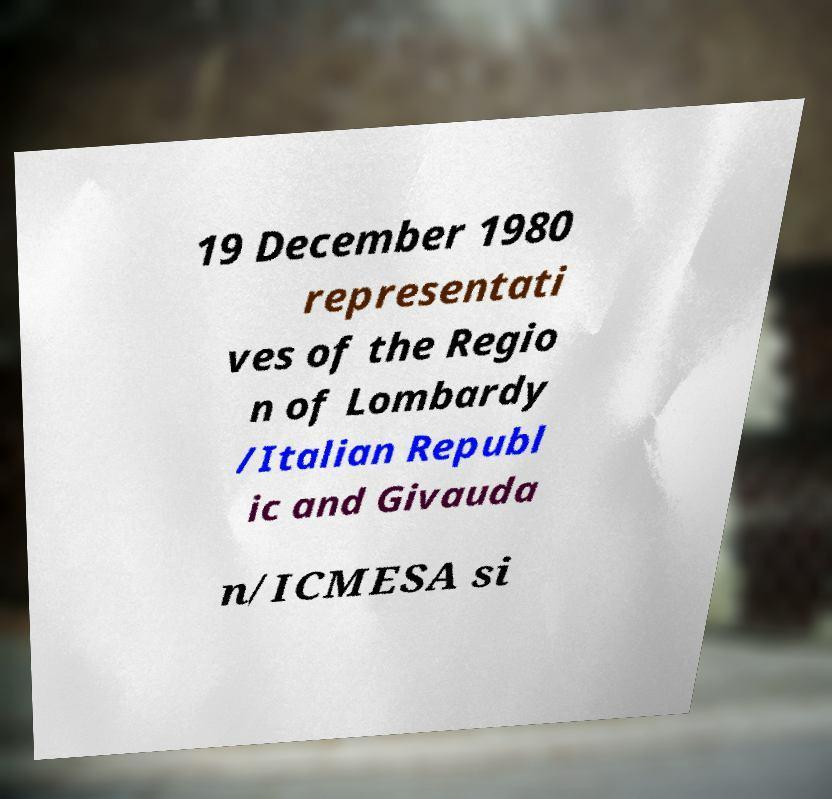Please identify and transcribe the text found in this image. 19 December 1980 representati ves of the Regio n of Lombardy /Italian Republ ic and Givauda n/ICMESA si 